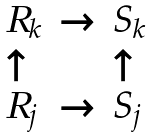<formula> <loc_0><loc_0><loc_500><loc_500>\begin{array} { l l l } R _ { k } & \rightarrow & S _ { k } \\ \uparrow & & \uparrow \\ R _ { j } & \rightarrow & S _ { j } \end{array}</formula> 